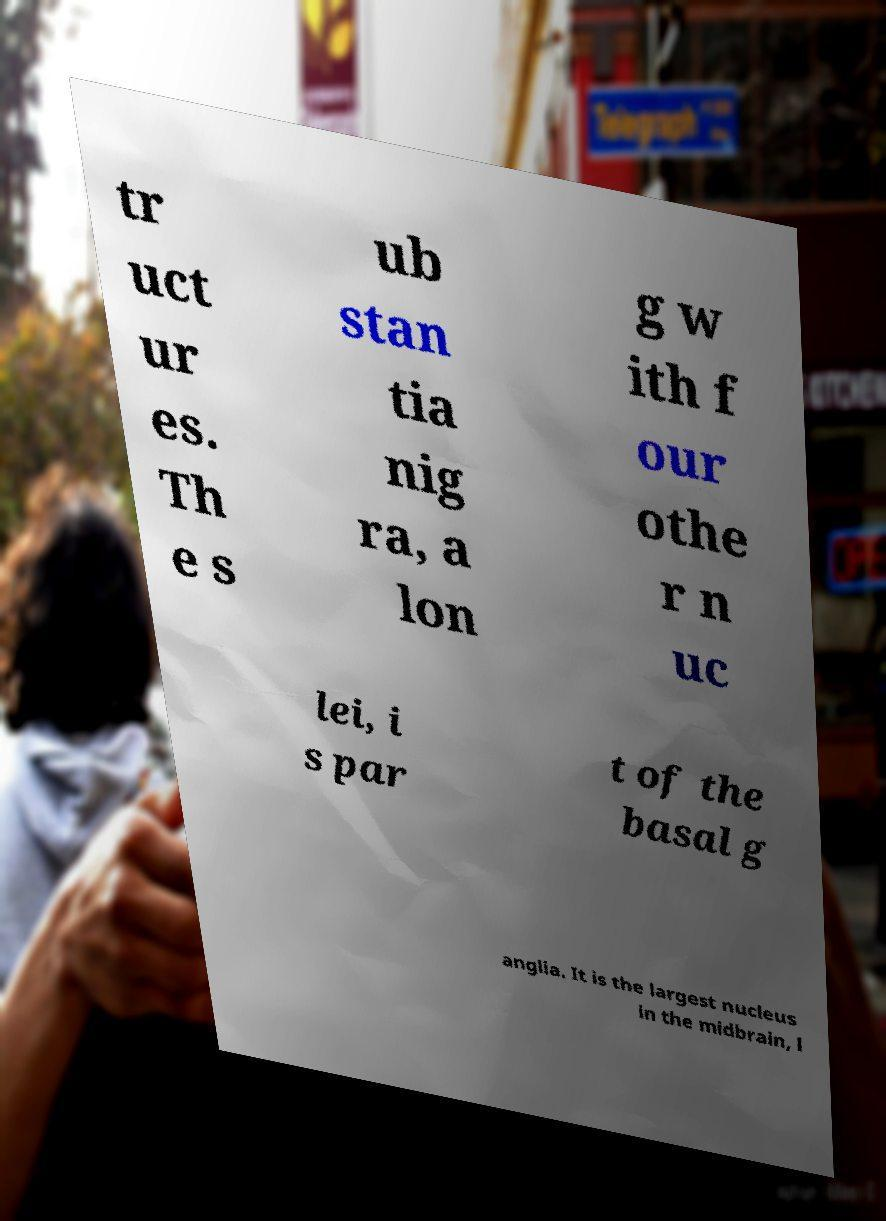There's text embedded in this image that I need extracted. Can you transcribe it verbatim? tr uct ur es. Th e s ub stan tia nig ra, a lon g w ith f our othe r n uc lei, i s par t of the basal g anglia. It is the largest nucleus in the midbrain, l 